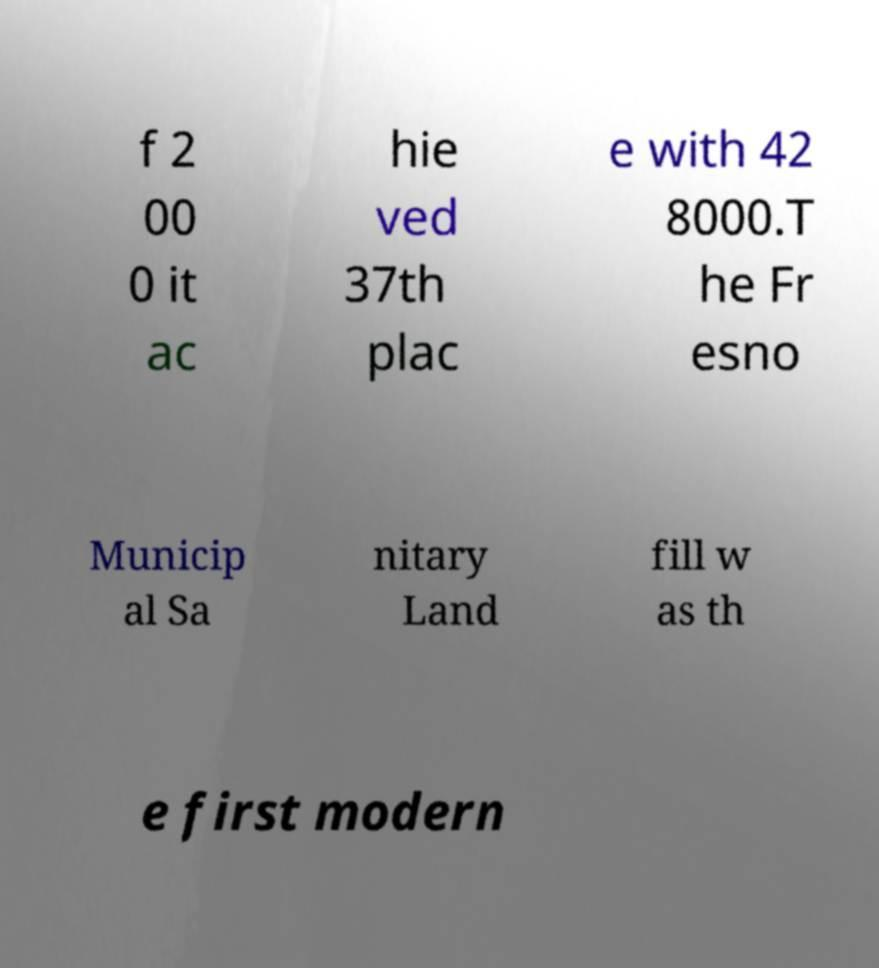For documentation purposes, I need the text within this image transcribed. Could you provide that? f 2 00 0 it ac hie ved 37th plac e with 42 8000.T he Fr esno Municip al Sa nitary Land fill w as th e first modern 